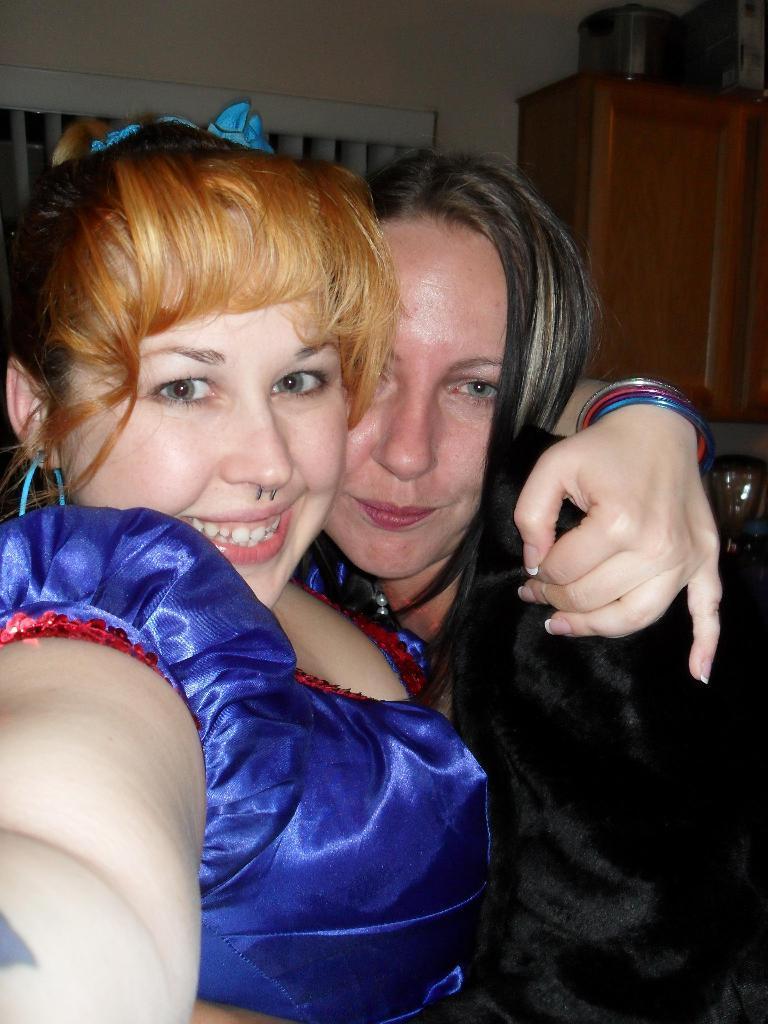Describe this image in one or two sentences. In this image there are two women with a smile on their face, behind the women there is curtain on the wall, beside the curtain there is an object on the wooden cupboard. 